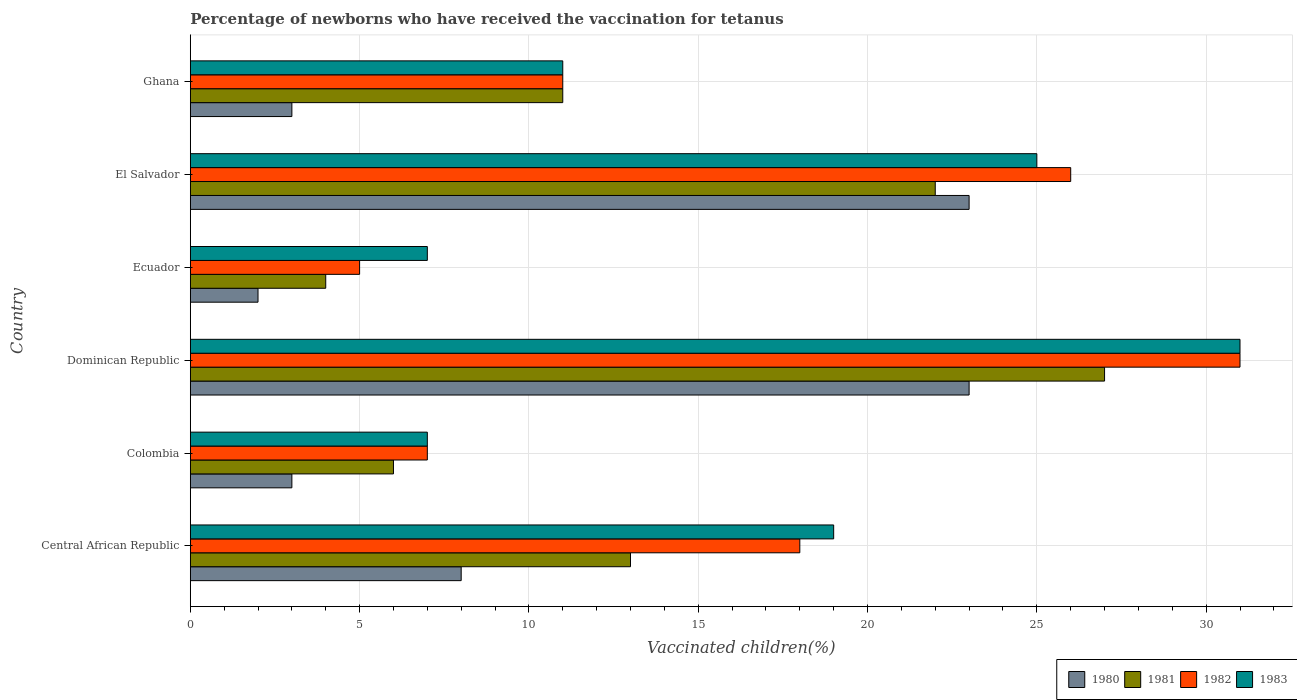How many groups of bars are there?
Make the answer very short. 6. Are the number of bars per tick equal to the number of legend labels?
Keep it short and to the point. Yes. Are the number of bars on each tick of the Y-axis equal?
Your answer should be compact. Yes. What is the label of the 6th group of bars from the top?
Your answer should be compact. Central African Republic. In how many cases, is the number of bars for a given country not equal to the number of legend labels?
Provide a short and direct response. 0. What is the percentage of vaccinated children in 1982 in Colombia?
Ensure brevity in your answer.  7. In which country was the percentage of vaccinated children in 1980 maximum?
Your answer should be very brief. Dominican Republic. In which country was the percentage of vaccinated children in 1980 minimum?
Your answer should be compact. Ecuador. What is the difference between the percentage of vaccinated children in 1980 in Dominican Republic and the percentage of vaccinated children in 1983 in Central African Republic?
Keep it short and to the point. 4. What is the average percentage of vaccinated children in 1980 per country?
Your answer should be very brief. 10.33. In how many countries, is the percentage of vaccinated children in 1982 greater than 17 %?
Your answer should be compact. 3. Is the difference between the percentage of vaccinated children in 1981 in Ecuador and El Salvador greater than the difference between the percentage of vaccinated children in 1980 in Ecuador and El Salvador?
Provide a succinct answer. Yes. In how many countries, is the percentage of vaccinated children in 1980 greater than the average percentage of vaccinated children in 1980 taken over all countries?
Your answer should be compact. 2. Is the sum of the percentage of vaccinated children in 1982 in Colombia and El Salvador greater than the maximum percentage of vaccinated children in 1983 across all countries?
Provide a short and direct response. Yes. Is it the case that in every country, the sum of the percentage of vaccinated children in 1982 and percentage of vaccinated children in 1983 is greater than the sum of percentage of vaccinated children in 1981 and percentage of vaccinated children in 1980?
Provide a short and direct response. No. How many bars are there?
Give a very brief answer. 24. Are all the bars in the graph horizontal?
Offer a terse response. Yes. How many countries are there in the graph?
Ensure brevity in your answer.  6. What is the difference between two consecutive major ticks on the X-axis?
Provide a succinct answer. 5. Does the graph contain any zero values?
Your response must be concise. No. Where does the legend appear in the graph?
Your answer should be compact. Bottom right. How are the legend labels stacked?
Keep it short and to the point. Horizontal. What is the title of the graph?
Provide a short and direct response. Percentage of newborns who have received the vaccination for tetanus. What is the label or title of the X-axis?
Provide a succinct answer. Vaccinated children(%). What is the Vaccinated children(%) in 1982 in Colombia?
Offer a very short reply. 7. What is the Vaccinated children(%) of 1983 in Colombia?
Provide a succinct answer. 7. What is the Vaccinated children(%) of 1980 in Dominican Republic?
Make the answer very short. 23. What is the Vaccinated children(%) of 1981 in Dominican Republic?
Offer a very short reply. 27. What is the Vaccinated children(%) in 1982 in Dominican Republic?
Provide a succinct answer. 31. What is the Vaccinated children(%) of 1980 in Ecuador?
Keep it short and to the point. 2. What is the Vaccinated children(%) of 1981 in Ecuador?
Your answer should be very brief. 4. What is the Vaccinated children(%) in 1982 in Ecuador?
Give a very brief answer. 5. What is the Vaccinated children(%) in 1980 in El Salvador?
Your response must be concise. 23. What is the Vaccinated children(%) in 1981 in Ghana?
Your response must be concise. 11. What is the Vaccinated children(%) of 1983 in Ghana?
Keep it short and to the point. 11. Across all countries, what is the minimum Vaccinated children(%) of 1980?
Give a very brief answer. 2. Across all countries, what is the minimum Vaccinated children(%) of 1982?
Your answer should be very brief. 5. What is the total Vaccinated children(%) of 1981 in the graph?
Give a very brief answer. 83. What is the total Vaccinated children(%) of 1982 in the graph?
Provide a succinct answer. 98. What is the total Vaccinated children(%) of 1983 in the graph?
Your answer should be very brief. 100. What is the difference between the Vaccinated children(%) in 1980 in Central African Republic and that in Colombia?
Provide a succinct answer. 5. What is the difference between the Vaccinated children(%) of 1982 in Central African Republic and that in Colombia?
Keep it short and to the point. 11. What is the difference between the Vaccinated children(%) in 1983 in Central African Republic and that in Colombia?
Make the answer very short. 12. What is the difference between the Vaccinated children(%) of 1983 in Central African Republic and that in Dominican Republic?
Make the answer very short. -12. What is the difference between the Vaccinated children(%) in 1983 in Central African Republic and that in Ecuador?
Offer a terse response. 12. What is the difference between the Vaccinated children(%) in 1983 in Central African Republic and that in El Salvador?
Ensure brevity in your answer.  -6. What is the difference between the Vaccinated children(%) of 1981 in Central African Republic and that in Ghana?
Offer a terse response. 2. What is the difference between the Vaccinated children(%) in 1982 in Central African Republic and that in Ghana?
Provide a short and direct response. 7. What is the difference between the Vaccinated children(%) of 1980 in Colombia and that in Dominican Republic?
Ensure brevity in your answer.  -20. What is the difference between the Vaccinated children(%) of 1982 in Colombia and that in Dominican Republic?
Make the answer very short. -24. What is the difference between the Vaccinated children(%) in 1982 in Colombia and that in Ecuador?
Your answer should be very brief. 2. What is the difference between the Vaccinated children(%) in 1983 in Colombia and that in Ecuador?
Provide a short and direct response. 0. What is the difference between the Vaccinated children(%) in 1980 in Colombia and that in El Salvador?
Your response must be concise. -20. What is the difference between the Vaccinated children(%) of 1981 in Colombia and that in El Salvador?
Offer a very short reply. -16. What is the difference between the Vaccinated children(%) of 1982 in Colombia and that in El Salvador?
Provide a short and direct response. -19. What is the difference between the Vaccinated children(%) in 1981 in Colombia and that in Ghana?
Make the answer very short. -5. What is the difference between the Vaccinated children(%) in 1982 in Colombia and that in Ghana?
Provide a short and direct response. -4. What is the difference between the Vaccinated children(%) in 1982 in Dominican Republic and that in Ecuador?
Give a very brief answer. 26. What is the difference between the Vaccinated children(%) in 1980 in Dominican Republic and that in El Salvador?
Offer a terse response. 0. What is the difference between the Vaccinated children(%) in 1981 in Dominican Republic and that in El Salvador?
Keep it short and to the point. 5. What is the difference between the Vaccinated children(%) of 1983 in Dominican Republic and that in El Salvador?
Make the answer very short. 6. What is the difference between the Vaccinated children(%) of 1980 in Dominican Republic and that in Ghana?
Make the answer very short. 20. What is the difference between the Vaccinated children(%) in 1982 in Dominican Republic and that in Ghana?
Ensure brevity in your answer.  20. What is the difference between the Vaccinated children(%) of 1980 in Ecuador and that in El Salvador?
Your response must be concise. -21. What is the difference between the Vaccinated children(%) in 1982 in Ecuador and that in El Salvador?
Give a very brief answer. -21. What is the difference between the Vaccinated children(%) of 1983 in Ecuador and that in El Salvador?
Provide a succinct answer. -18. What is the difference between the Vaccinated children(%) in 1982 in Ecuador and that in Ghana?
Ensure brevity in your answer.  -6. What is the difference between the Vaccinated children(%) of 1983 in Ecuador and that in Ghana?
Ensure brevity in your answer.  -4. What is the difference between the Vaccinated children(%) of 1981 in El Salvador and that in Ghana?
Provide a succinct answer. 11. What is the difference between the Vaccinated children(%) in 1982 in El Salvador and that in Ghana?
Make the answer very short. 15. What is the difference between the Vaccinated children(%) in 1983 in El Salvador and that in Ghana?
Offer a very short reply. 14. What is the difference between the Vaccinated children(%) in 1980 in Central African Republic and the Vaccinated children(%) in 1981 in Colombia?
Ensure brevity in your answer.  2. What is the difference between the Vaccinated children(%) in 1980 in Central African Republic and the Vaccinated children(%) in 1982 in Colombia?
Keep it short and to the point. 1. What is the difference between the Vaccinated children(%) of 1980 in Central African Republic and the Vaccinated children(%) of 1983 in Colombia?
Offer a terse response. 1. What is the difference between the Vaccinated children(%) in 1981 in Central African Republic and the Vaccinated children(%) in 1983 in Colombia?
Your answer should be very brief. 6. What is the difference between the Vaccinated children(%) in 1980 in Central African Republic and the Vaccinated children(%) in 1981 in Dominican Republic?
Your answer should be compact. -19. What is the difference between the Vaccinated children(%) in 1980 in Central African Republic and the Vaccinated children(%) in 1982 in Dominican Republic?
Provide a short and direct response. -23. What is the difference between the Vaccinated children(%) of 1980 in Central African Republic and the Vaccinated children(%) of 1983 in Dominican Republic?
Your answer should be very brief. -23. What is the difference between the Vaccinated children(%) in 1981 in Central African Republic and the Vaccinated children(%) in 1983 in Dominican Republic?
Your response must be concise. -18. What is the difference between the Vaccinated children(%) in 1980 in Central African Republic and the Vaccinated children(%) in 1983 in Ecuador?
Provide a short and direct response. 1. What is the difference between the Vaccinated children(%) in 1980 in Central African Republic and the Vaccinated children(%) in 1981 in El Salvador?
Give a very brief answer. -14. What is the difference between the Vaccinated children(%) of 1981 in Central African Republic and the Vaccinated children(%) of 1982 in El Salvador?
Offer a terse response. -13. What is the difference between the Vaccinated children(%) of 1981 in Central African Republic and the Vaccinated children(%) of 1983 in El Salvador?
Offer a very short reply. -12. What is the difference between the Vaccinated children(%) of 1982 in Central African Republic and the Vaccinated children(%) of 1983 in El Salvador?
Provide a succinct answer. -7. What is the difference between the Vaccinated children(%) of 1980 in Central African Republic and the Vaccinated children(%) of 1982 in Ghana?
Give a very brief answer. -3. What is the difference between the Vaccinated children(%) in 1980 in Colombia and the Vaccinated children(%) in 1983 in Dominican Republic?
Ensure brevity in your answer.  -28. What is the difference between the Vaccinated children(%) of 1981 in Colombia and the Vaccinated children(%) of 1982 in Dominican Republic?
Offer a very short reply. -25. What is the difference between the Vaccinated children(%) of 1981 in Colombia and the Vaccinated children(%) of 1983 in Dominican Republic?
Ensure brevity in your answer.  -25. What is the difference between the Vaccinated children(%) of 1982 in Colombia and the Vaccinated children(%) of 1983 in Dominican Republic?
Ensure brevity in your answer.  -24. What is the difference between the Vaccinated children(%) of 1980 in Colombia and the Vaccinated children(%) of 1981 in Ecuador?
Offer a very short reply. -1. What is the difference between the Vaccinated children(%) of 1980 in Colombia and the Vaccinated children(%) of 1983 in Ecuador?
Your answer should be very brief. -4. What is the difference between the Vaccinated children(%) in 1981 in Colombia and the Vaccinated children(%) in 1983 in Ecuador?
Provide a short and direct response. -1. What is the difference between the Vaccinated children(%) of 1982 in Colombia and the Vaccinated children(%) of 1983 in Ecuador?
Give a very brief answer. 0. What is the difference between the Vaccinated children(%) of 1981 in Colombia and the Vaccinated children(%) of 1982 in El Salvador?
Ensure brevity in your answer.  -20. What is the difference between the Vaccinated children(%) of 1980 in Colombia and the Vaccinated children(%) of 1981 in Ghana?
Your response must be concise. -8. What is the difference between the Vaccinated children(%) of 1980 in Colombia and the Vaccinated children(%) of 1982 in Ghana?
Offer a very short reply. -8. What is the difference between the Vaccinated children(%) in 1980 in Colombia and the Vaccinated children(%) in 1983 in Ghana?
Offer a very short reply. -8. What is the difference between the Vaccinated children(%) in 1981 in Colombia and the Vaccinated children(%) in 1983 in Ghana?
Your answer should be very brief. -5. What is the difference between the Vaccinated children(%) in 1982 in Colombia and the Vaccinated children(%) in 1983 in Ghana?
Your answer should be compact. -4. What is the difference between the Vaccinated children(%) in 1980 in Dominican Republic and the Vaccinated children(%) in 1982 in Ecuador?
Offer a terse response. 18. What is the difference between the Vaccinated children(%) in 1981 in Dominican Republic and the Vaccinated children(%) in 1983 in Ecuador?
Offer a terse response. 20. What is the difference between the Vaccinated children(%) of 1980 in Dominican Republic and the Vaccinated children(%) of 1982 in El Salvador?
Make the answer very short. -3. What is the difference between the Vaccinated children(%) of 1980 in Dominican Republic and the Vaccinated children(%) of 1983 in El Salvador?
Offer a very short reply. -2. What is the difference between the Vaccinated children(%) in 1981 in Dominican Republic and the Vaccinated children(%) in 1983 in El Salvador?
Your response must be concise. 2. What is the difference between the Vaccinated children(%) of 1982 in Dominican Republic and the Vaccinated children(%) of 1983 in El Salvador?
Ensure brevity in your answer.  6. What is the difference between the Vaccinated children(%) in 1980 in Dominican Republic and the Vaccinated children(%) in 1982 in Ghana?
Offer a very short reply. 12. What is the difference between the Vaccinated children(%) of 1980 in Dominican Republic and the Vaccinated children(%) of 1983 in Ghana?
Offer a very short reply. 12. What is the difference between the Vaccinated children(%) of 1981 in Dominican Republic and the Vaccinated children(%) of 1982 in Ghana?
Your response must be concise. 16. What is the difference between the Vaccinated children(%) in 1981 in Dominican Republic and the Vaccinated children(%) in 1983 in Ghana?
Make the answer very short. 16. What is the difference between the Vaccinated children(%) in 1980 in Ecuador and the Vaccinated children(%) in 1982 in El Salvador?
Offer a very short reply. -24. What is the difference between the Vaccinated children(%) of 1980 in Ecuador and the Vaccinated children(%) of 1983 in El Salvador?
Your response must be concise. -23. What is the difference between the Vaccinated children(%) of 1981 in Ecuador and the Vaccinated children(%) of 1982 in El Salvador?
Provide a short and direct response. -22. What is the difference between the Vaccinated children(%) in 1982 in Ecuador and the Vaccinated children(%) in 1983 in El Salvador?
Ensure brevity in your answer.  -20. What is the difference between the Vaccinated children(%) of 1980 in Ecuador and the Vaccinated children(%) of 1982 in Ghana?
Your answer should be compact. -9. What is the difference between the Vaccinated children(%) in 1981 in Ecuador and the Vaccinated children(%) in 1983 in Ghana?
Offer a very short reply. -7. What is the difference between the Vaccinated children(%) in 1980 in El Salvador and the Vaccinated children(%) in 1982 in Ghana?
Ensure brevity in your answer.  12. What is the difference between the Vaccinated children(%) of 1980 in El Salvador and the Vaccinated children(%) of 1983 in Ghana?
Give a very brief answer. 12. What is the difference between the Vaccinated children(%) of 1981 in El Salvador and the Vaccinated children(%) of 1983 in Ghana?
Offer a terse response. 11. What is the average Vaccinated children(%) of 1980 per country?
Your answer should be very brief. 10.33. What is the average Vaccinated children(%) in 1981 per country?
Keep it short and to the point. 13.83. What is the average Vaccinated children(%) of 1982 per country?
Give a very brief answer. 16.33. What is the average Vaccinated children(%) of 1983 per country?
Your response must be concise. 16.67. What is the difference between the Vaccinated children(%) in 1980 and Vaccinated children(%) in 1981 in Central African Republic?
Give a very brief answer. -5. What is the difference between the Vaccinated children(%) in 1980 and Vaccinated children(%) in 1982 in Central African Republic?
Make the answer very short. -10. What is the difference between the Vaccinated children(%) in 1981 and Vaccinated children(%) in 1982 in Central African Republic?
Give a very brief answer. -5. What is the difference between the Vaccinated children(%) in 1982 and Vaccinated children(%) in 1983 in Central African Republic?
Provide a succinct answer. -1. What is the difference between the Vaccinated children(%) in 1981 and Vaccinated children(%) in 1982 in Colombia?
Your answer should be compact. -1. What is the difference between the Vaccinated children(%) in 1982 and Vaccinated children(%) in 1983 in Colombia?
Your response must be concise. 0. What is the difference between the Vaccinated children(%) of 1980 and Vaccinated children(%) of 1981 in Dominican Republic?
Offer a very short reply. -4. What is the difference between the Vaccinated children(%) of 1980 and Vaccinated children(%) of 1982 in Dominican Republic?
Give a very brief answer. -8. What is the difference between the Vaccinated children(%) in 1982 and Vaccinated children(%) in 1983 in Dominican Republic?
Give a very brief answer. 0. What is the difference between the Vaccinated children(%) in 1980 and Vaccinated children(%) in 1981 in Ecuador?
Keep it short and to the point. -2. What is the difference between the Vaccinated children(%) of 1980 and Vaccinated children(%) of 1983 in Ecuador?
Provide a short and direct response. -5. What is the difference between the Vaccinated children(%) of 1981 and Vaccinated children(%) of 1982 in Ecuador?
Provide a short and direct response. -1. What is the difference between the Vaccinated children(%) of 1982 and Vaccinated children(%) of 1983 in Ecuador?
Keep it short and to the point. -2. What is the difference between the Vaccinated children(%) of 1980 and Vaccinated children(%) of 1983 in El Salvador?
Keep it short and to the point. -2. What is the difference between the Vaccinated children(%) in 1981 and Vaccinated children(%) in 1982 in El Salvador?
Make the answer very short. -4. What is the difference between the Vaccinated children(%) of 1981 and Vaccinated children(%) of 1983 in El Salvador?
Make the answer very short. -3. What is the difference between the Vaccinated children(%) of 1980 and Vaccinated children(%) of 1982 in Ghana?
Ensure brevity in your answer.  -8. What is the difference between the Vaccinated children(%) of 1980 and Vaccinated children(%) of 1983 in Ghana?
Your answer should be very brief. -8. What is the difference between the Vaccinated children(%) in 1982 and Vaccinated children(%) in 1983 in Ghana?
Your response must be concise. 0. What is the ratio of the Vaccinated children(%) of 1980 in Central African Republic to that in Colombia?
Your answer should be compact. 2.67. What is the ratio of the Vaccinated children(%) of 1981 in Central African Republic to that in Colombia?
Keep it short and to the point. 2.17. What is the ratio of the Vaccinated children(%) of 1982 in Central African Republic to that in Colombia?
Make the answer very short. 2.57. What is the ratio of the Vaccinated children(%) in 1983 in Central African Republic to that in Colombia?
Provide a short and direct response. 2.71. What is the ratio of the Vaccinated children(%) in 1980 in Central African Republic to that in Dominican Republic?
Ensure brevity in your answer.  0.35. What is the ratio of the Vaccinated children(%) in 1981 in Central African Republic to that in Dominican Republic?
Make the answer very short. 0.48. What is the ratio of the Vaccinated children(%) of 1982 in Central African Republic to that in Dominican Republic?
Your answer should be very brief. 0.58. What is the ratio of the Vaccinated children(%) of 1983 in Central African Republic to that in Dominican Republic?
Provide a succinct answer. 0.61. What is the ratio of the Vaccinated children(%) in 1981 in Central African Republic to that in Ecuador?
Offer a terse response. 3.25. What is the ratio of the Vaccinated children(%) of 1982 in Central African Republic to that in Ecuador?
Provide a succinct answer. 3.6. What is the ratio of the Vaccinated children(%) of 1983 in Central African Republic to that in Ecuador?
Offer a terse response. 2.71. What is the ratio of the Vaccinated children(%) in 1980 in Central African Republic to that in El Salvador?
Your answer should be compact. 0.35. What is the ratio of the Vaccinated children(%) in 1981 in Central African Republic to that in El Salvador?
Ensure brevity in your answer.  0.59. What is the ratio of the Vaccinated children(%) in 1982 in Central African Republic to that in El Salvador?
Keep it short and to the point. 0.69. What is the ratio of the Vaccinated children(%) in 1983 in Central African Republic to that in El Salvador?
Make the answer very short. 0.76. What is the ratio of the Vaccinated children(%) in 1980 in Central African Republic to that in Ghana?
Offer a terse response. 2.67. What is the ratio of the Vaccinated children(%) in 1981 in Central African Republic to that in Ghana?
Give a very brief answer. 1.18. What is the ratio of the Vaccinated children(%) of 1982 in Central African Republic to that in Ghana?
Offer a terse response. 1.64. What is the ratio of the Vaccinated children(%) of 1983 in Central African Republic to that in Ghana?
Provide a succinct answer. 1.73. What is the ratio of the Vaccinated children(%) in 1980 in Colombia to that in Dominican Republic?
Give a very brief answer. 0.13. What is the ratio of the Vaccinated children(%) in 1981 in Colombia to that in Dominican Republic?
Provide a succinct answer. 0.22. What is the ratio of the Vaccinated children(%) of 1982 in Colombia to that in Dominican Republic?
Provide a short and direct response. 0.23. What is the ratio of the Vaccinated children(%) of 1983 in Colombia to that in Dominican Republic?
Give a very brief answer. 0.23. What is the ratio of the Vaccinated children(%) in 1980 in Colombia to that in Ecuador?
Give a very brief answer. 1.5. What is the ratio of the Vaccinated children(%) in 1983 in Colombia to that in Ecuador?
Keep it short and to the point. 1. What is the ratio of the Vaccinated children(%) of 1980 in Colombia to that in El Salvador?
Your response must be concise. 0.13. What is the ratio of the Vaccinated children(%) in 1981 in Colombia to that in El Salvador?
Provide a short and direct response. 0.27. What is the ratio of the Vaccinated children(%) of 1982 in Colombia to that in El Salvador?
Keep it short and to the point. 0.27. What is the ratio of the Vaccinated children(%) in 1983 in Colombia to that in El Salvador?
Your answer should be compact. 0.28. What is the ratio of the Vaccinated children(%) in 1981 in Colombia to that in Ghana?
Offer a terse response. 0.55. What is the ratio of the Vaccinated children(%) of 1982 in Colombia to that in Ghana?
Provide a short and direct response. 0.64. What is the ratio of the Vaccinated children(%) in 1983 in Colombia to that in Ghana?
Ensure brevity in your answer.  0.64. What is the ratio of the Vaccinated children(%) of 1981 in Dominican Republic to that in Ecuador?
Make the answer very short. 6.75. What is the ratio of the Vaccinated children(%) in 1983 in Dominican Republic to that in Ecuador?
Offer a terse response. 4.43. What is the ratio of the Vaccinated children(%) in 1981 in Dominican Republic to that in El Salvador?
Your response must be concise. 1.23. What is the ratio of the Vaccinated children(%) of 1982 in Dominican Republic to that in El Salvador?
Offer a terse response. 1.19. What is the ratio of the Vaccinated children(%) of 1983 in Dominican Republic to that in El Salvador?
Give a very brief answer. 1.24. What is the ratio of the Vaccinated children(%) in 1980 in Dominican Republic to that in Ghana?
Keep it short and to the point. 7.67. What is the ratio of the Vaccinated children(%) in 1981 in Dominican Republic to that in Ghana?
Provide a succinct answer. 2.45. What is the ratio of the Vaccinated children(%) of 1982 in Dominican Republic to that in Ghana?
Make the answer very short. 2.82. What is the ratio of the Vaccinated children(%) in 1983 in Dominican Republic to that in Ghana?
Your answer should be compact. 2.82. What is the ratio of the Vaccinated children(%) in 1980 in Ecuador to that in El Salvador?
Offer a very short reply. 0.09. What is the ratio of the Vaccinated children(%) of 1981 in Ecuador to that in El Salvador?
Provide a short and direct response. 0.18. What is the ratio of the Vaccinated children(%) in 1982 in Ecuador to that in El Salvador?
Provide a succinct answer. 0.19. What is the ratio of the Vaccinated children(%) of 1983 in Ecuador to that in El Salvador?
Your response must be concise. 0.28. What is the ratio of the Vaccinated children(%) of 1981 in Ecuador to that in Ghana?
Ensure brevity in your answer.  0.36. What is the ratio of the Vaccinated children(%) of 1982 in Ecuador to that in Ghana?
Ensure brevity in your answer.  0.45. What is the ratio of the Vaccinated children(%) of 1983 in Ecuador to that in Ghana?
Offer a very short reply. 0.64. What is the ratio of the Vaccinated children(%) in 1980 in El Salvador to that in Ghana?
Give a very brief answer. 7.67. What is the ratio of the Vaccinated children(%) in 1981 in El Salvador to that in Ghana?
Provide a short and direct response. 2. What is the ratio of the Vaccinated children(%) in 1982 in El Salvador to that in Ghana?
Offer a terse response. 2.36. What is the ratio of the Vaccinated children(%) of 1983 in El Salvador to that in Ghana?
Offer a terse response. 2.27. What is the difference between the highest and the second highest Vaccinated children(%) of 1982?
Give a very brief answer. 5. What is the difference between the highest and the second highest Vaccinated children(%) of 1983?
Your response must be concise. 6. What is the difference between the highest and the lowest Vaccinated children(%) of 1980?
Offer a very short reply. 21. What is the difference between the highest and the lowest Vaccinated children(%) of 1981?
Keep it short and to the point. 23. What is the difference between the highest and the lowest Vaccinated children(%) in 1983?
Your answer should be very brief. 24. 